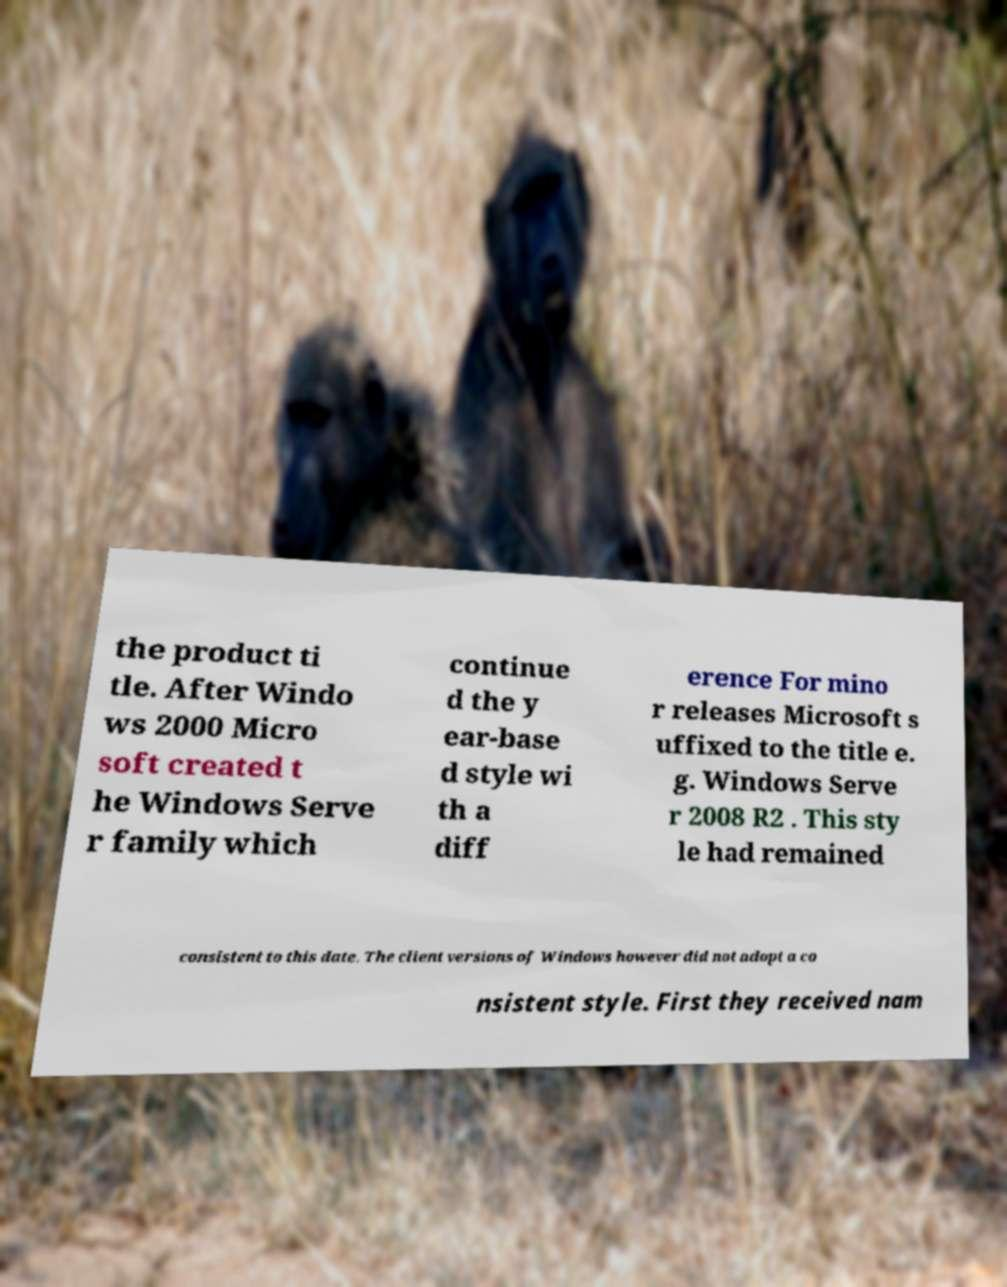Please identify and transcribe the text found in this image. the product ti tle. After Windo ws 2000 Micro soft created t he Windows Serve r family which continue d the y ear-base d style wi th a diff erence For mino r releases Microsoft s uffixed to the title e. g. Windows Serve r 2008 R2 . This sty le had remained consistent to this date. The client versions of Windows however did not adopt a co nsistent style. First they received nam 